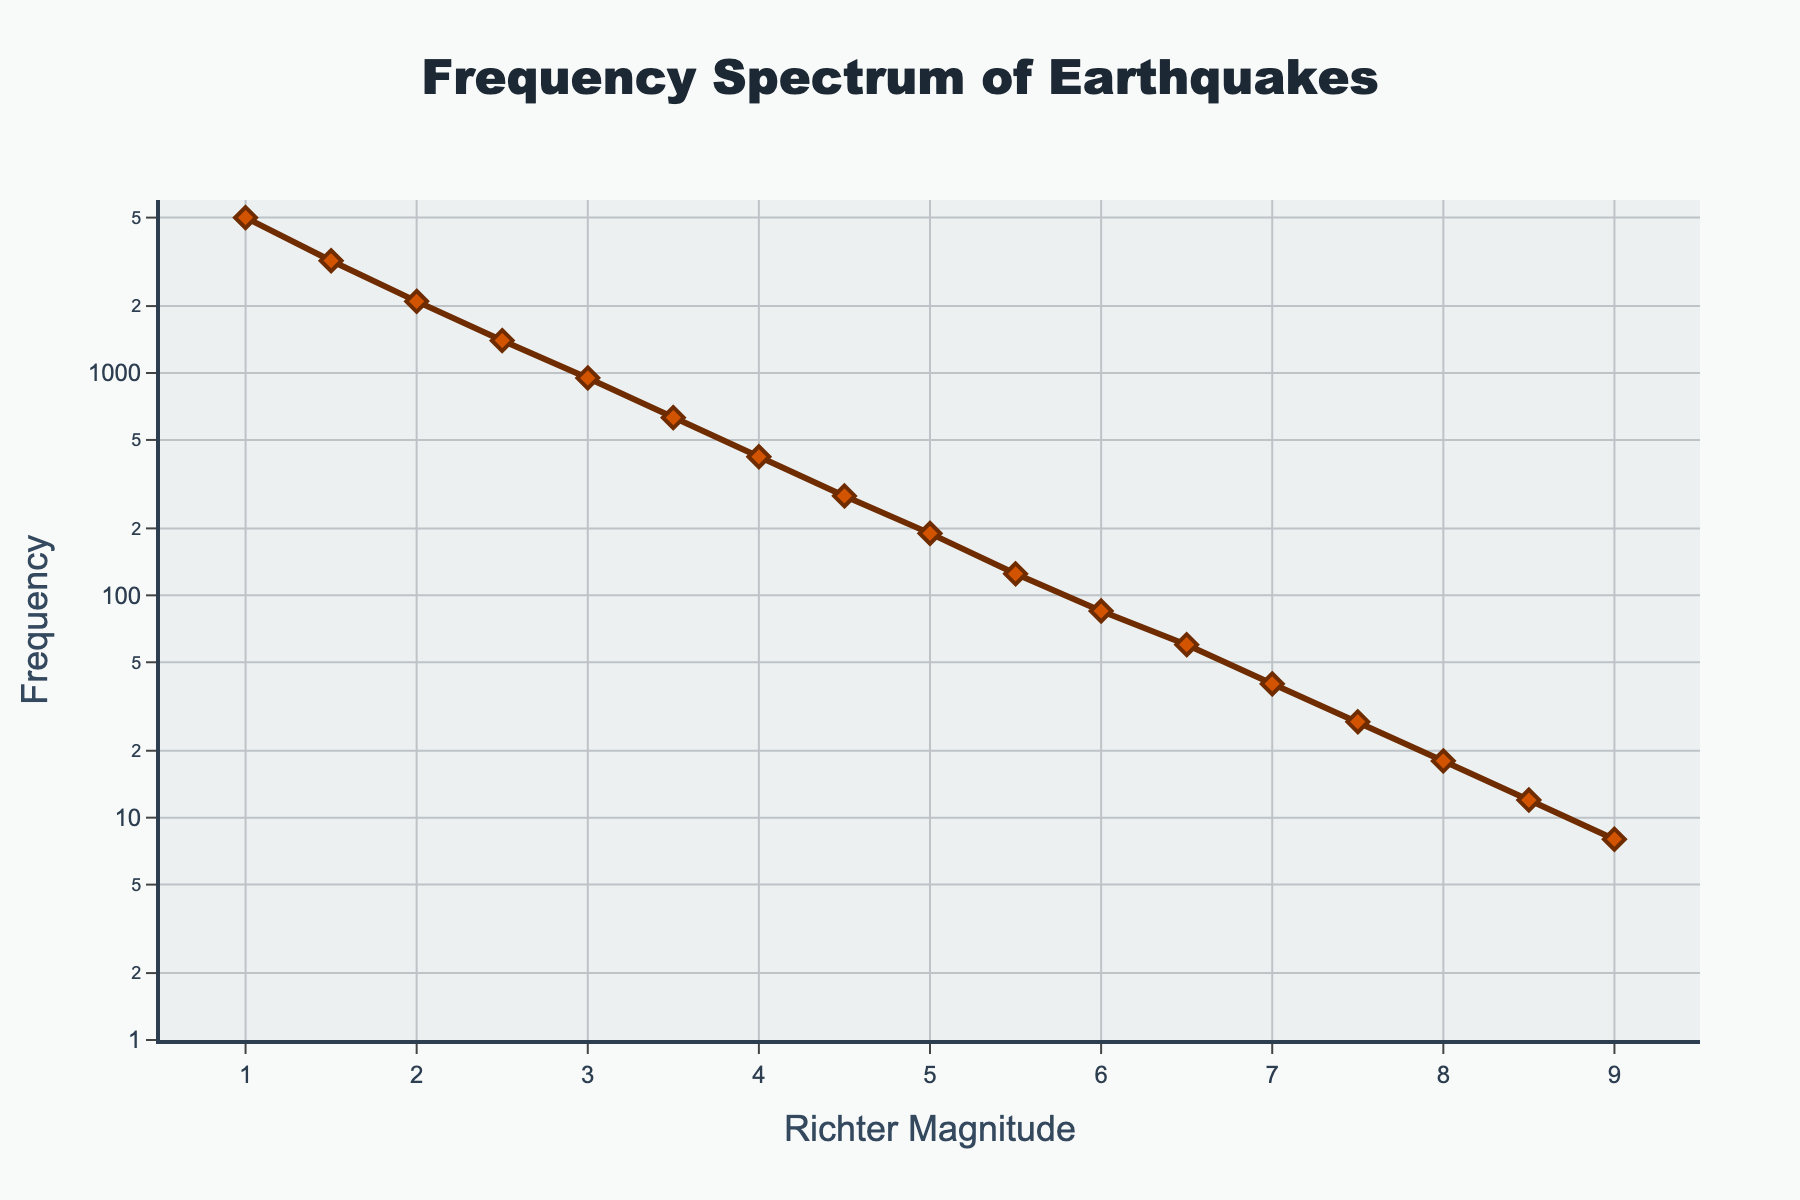What is the title of the figure? The title is prominently displayed at the top of the figure. It signifies the main subject of the plot.
Answer: Frequency Spectrum of Earthquakes What are the labels on the x-axis and y-axis? The x-axis label indicates the horizontal axis variable, and the y-axis label indicates the vertical axis variable.
Answer: Richter Magnitude and Frequency How many data points are there in the plot? Each marker on the line represents a data point, which corresponds to an earthquake event with a specific magnitude and frequency. Counting these markers gives the total number of data points.
Answer: 17 At which Richter Magnitude does the frequency drop below 100? Observe the data points on the line plot to find the magnitude at which the frequency value falls below 100.
Answer: 6.5 Which magnitude has the highest frequency of earthquakes? Locate the highest value on the y-axis and find the corresponding x-axis value.
Answer: 1.0 How does the frequency change as the Richter Magnitude increases from 1.0 to 9.0? Analyze the trend of the line plot from left (lower magnitude) to right (higher magnitude). Note the general direction and rate of change.
Answer: Decreases sharply What is the difference in frequency between earthquakes of magnitudes 2.5 and 3.0? Identify the frequencies corresponding to magnitudes 2.5 and 3.0, then subtract the smaller frequency from the larger one.
Answer: 450 What is the average frequency of earthquakes for magnitudes between 5.0 to 6.0? Find the frequencies for magnitudes 5.0, 5.5, and 6.0. Calculate their sum and then divide by the number of magnitudes considered.
Answer: 133.33 How does the log scale on the y-axis affect the visual representation of the frequency data? The log scale compresses the lower frequency values, allowing for better visualization of the wide range of earthquake frequencies. It makes exponential trends appear linear.
Answer: Enhances visualization of wide frequency range Which magnitude range shows the steepest decline in frequency? Observe the segments of the line plot and identify where the slope is steepest, indicating the most rapid decrease in frequency.
Answer: 1.0 to 2.0 Compare the frequencies of earthquakes at magnitudes 4.0 and 7.0. Which is higher and by how much? Identify the frequencies for magnitudes 4.0 and 7.0. Subtract the smaller frequency from the larger one to find the difference.
Answer: 4.0 is higher by 380 